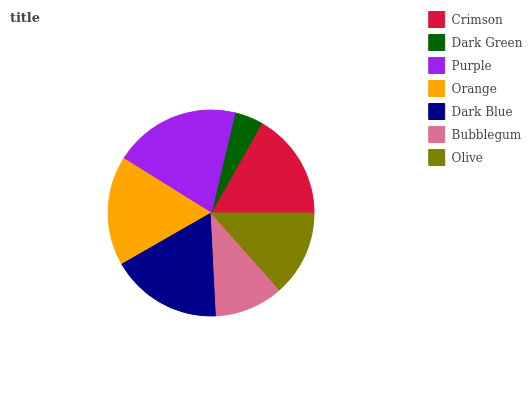Is Dark Green the minimum?
Answer yes or no. Yes. Is Purple the maximum?
Answer yes or no. Yes. Is Purple the minimum?
Answer yes or no. No. Is Dark Green the maximum?
Answer yes or no. No. Is Purple greater than Dark Green?
Answer yes or no. Yes. Is Dark Green less than Purple?
Answer yes or no. Yes. Is Dark Green greater than Purple?
Answer yes or no. No. Is Purple less than Dark Green?
Answer yes or no. No. Is Crimson the high median?
Answer yes or no. Yes. Is Crimson the low median?
Answer yes or no. Yes. Is Dark Blue the high median?
Answer yes or no. No. Is Dark Blue the low median?
Answer yes or no. No. 